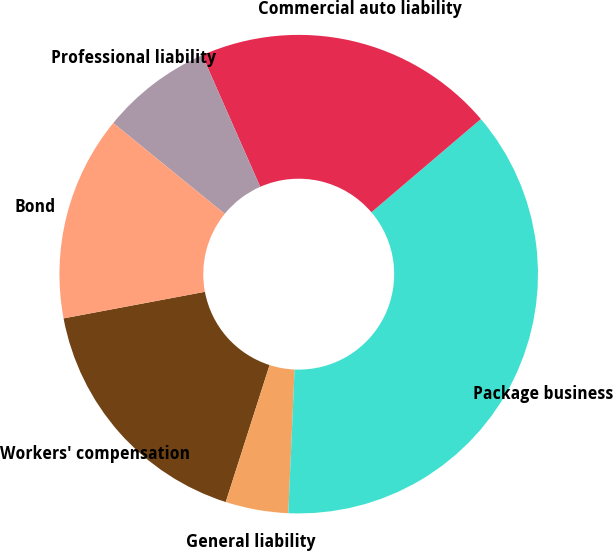Convert chart. <chart><loc_0><loc_0><loc_500><loc_500><pie_chart><fcel>Workers' compensation<fcel>General liability<fcel>Package business<fcel>Commercial auto liability<fcel>Professional liability<fcel>Bond<nl><fcel>17.11%<fcel>4.24%<fcel>36.92%<fcel>20.38%<fcel>7.51%<fcel>13.84%<nl></chart> 